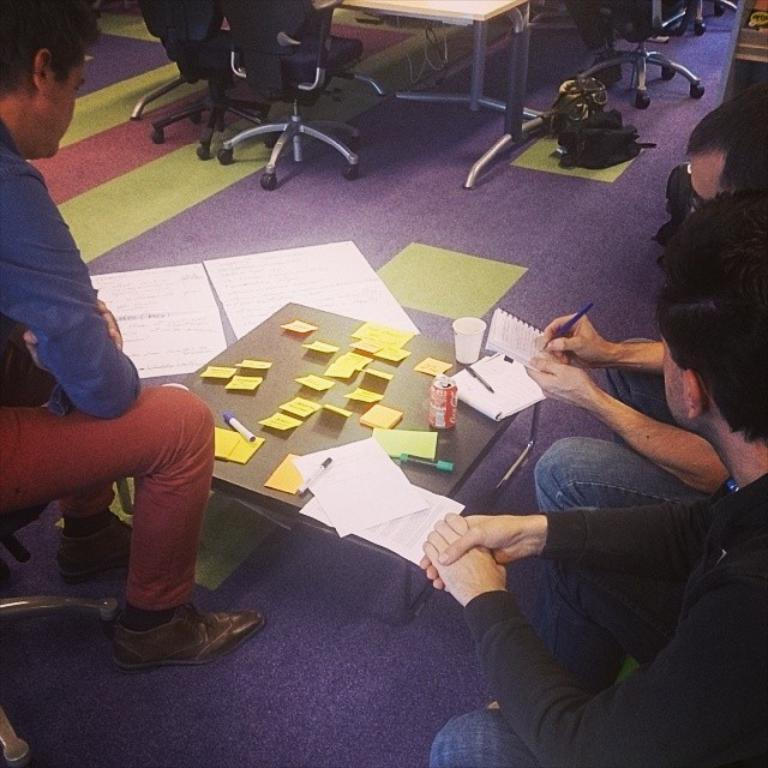How many people are in the image? There is a group of persons in the image. What are the persons doing in the image? The persons are sitting around a table. What objects can be seen on the table? There are papers and a coke tin on the table. What type of quilt is being used by the monkey in the image? There is no monkey present in the image, and therefore no quilt can be observed. 